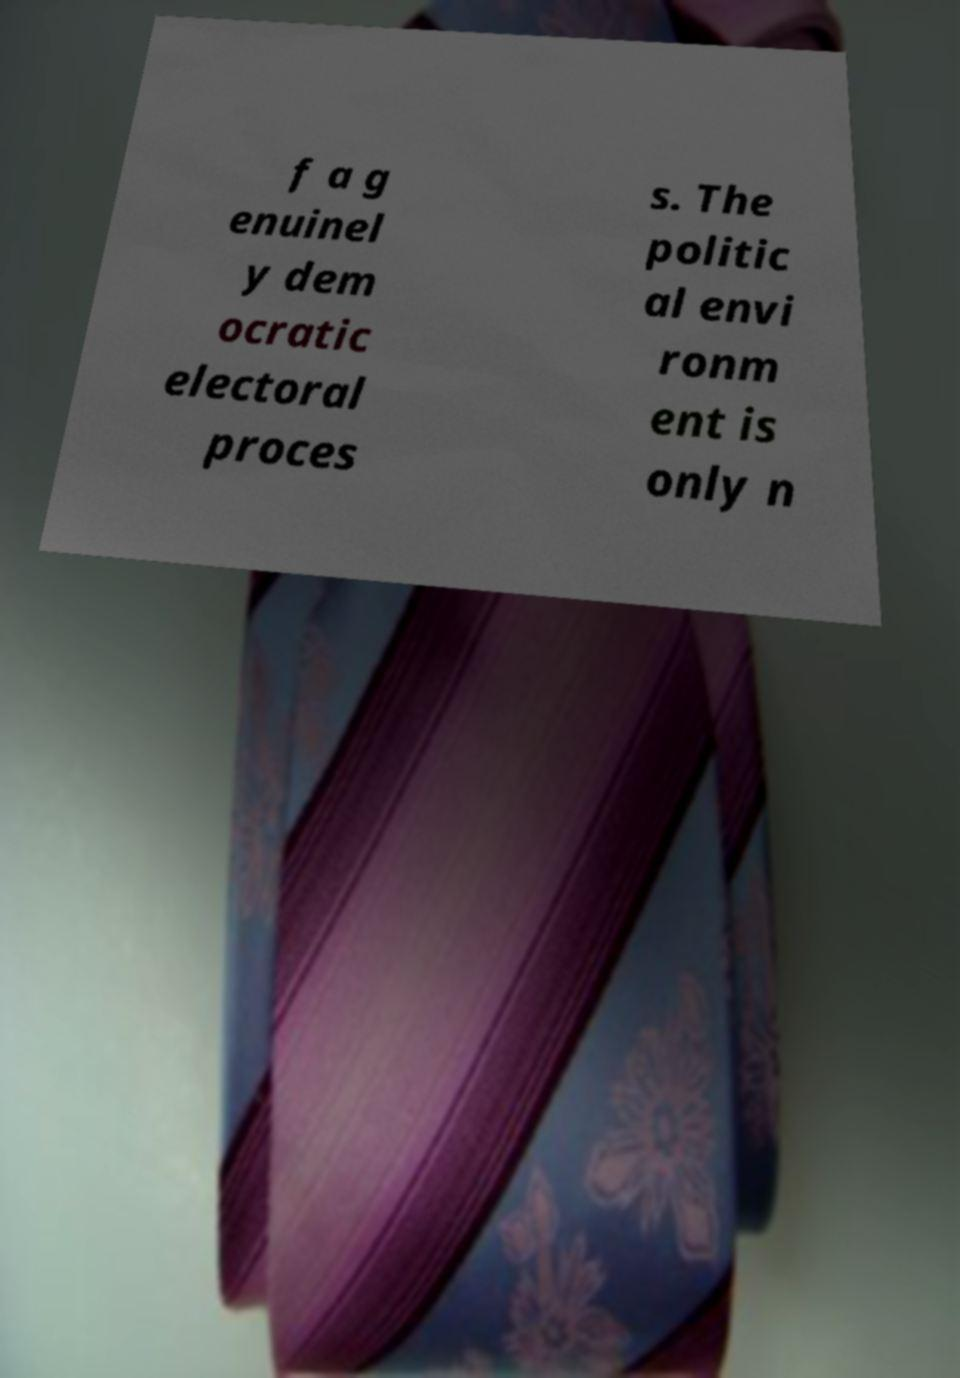Could you assist in decoding the text presented in this image and type it out clearly? f a g enuinel y dem ocratic electoral proces s. The politic al envi ronm ent is only n 